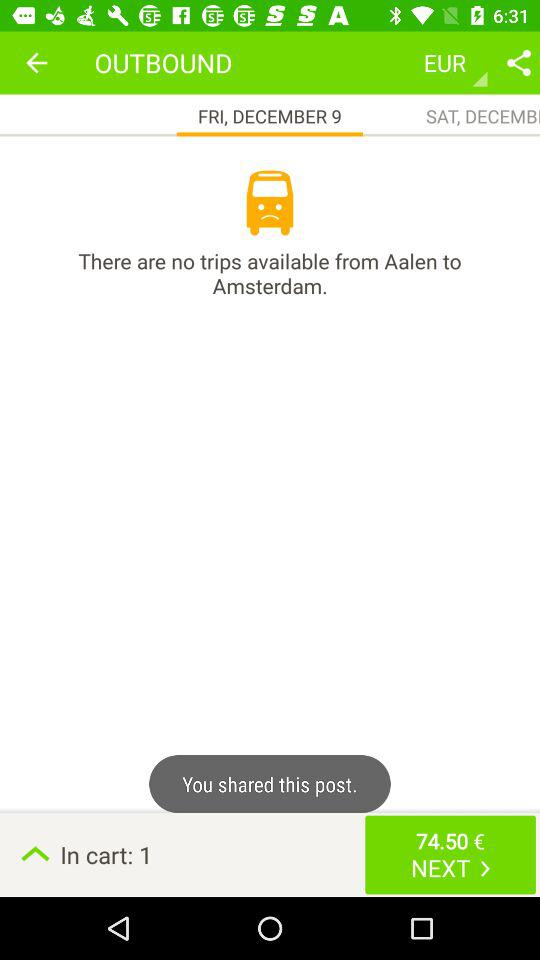What is the given amount? The given amount is 74.50 euros. 